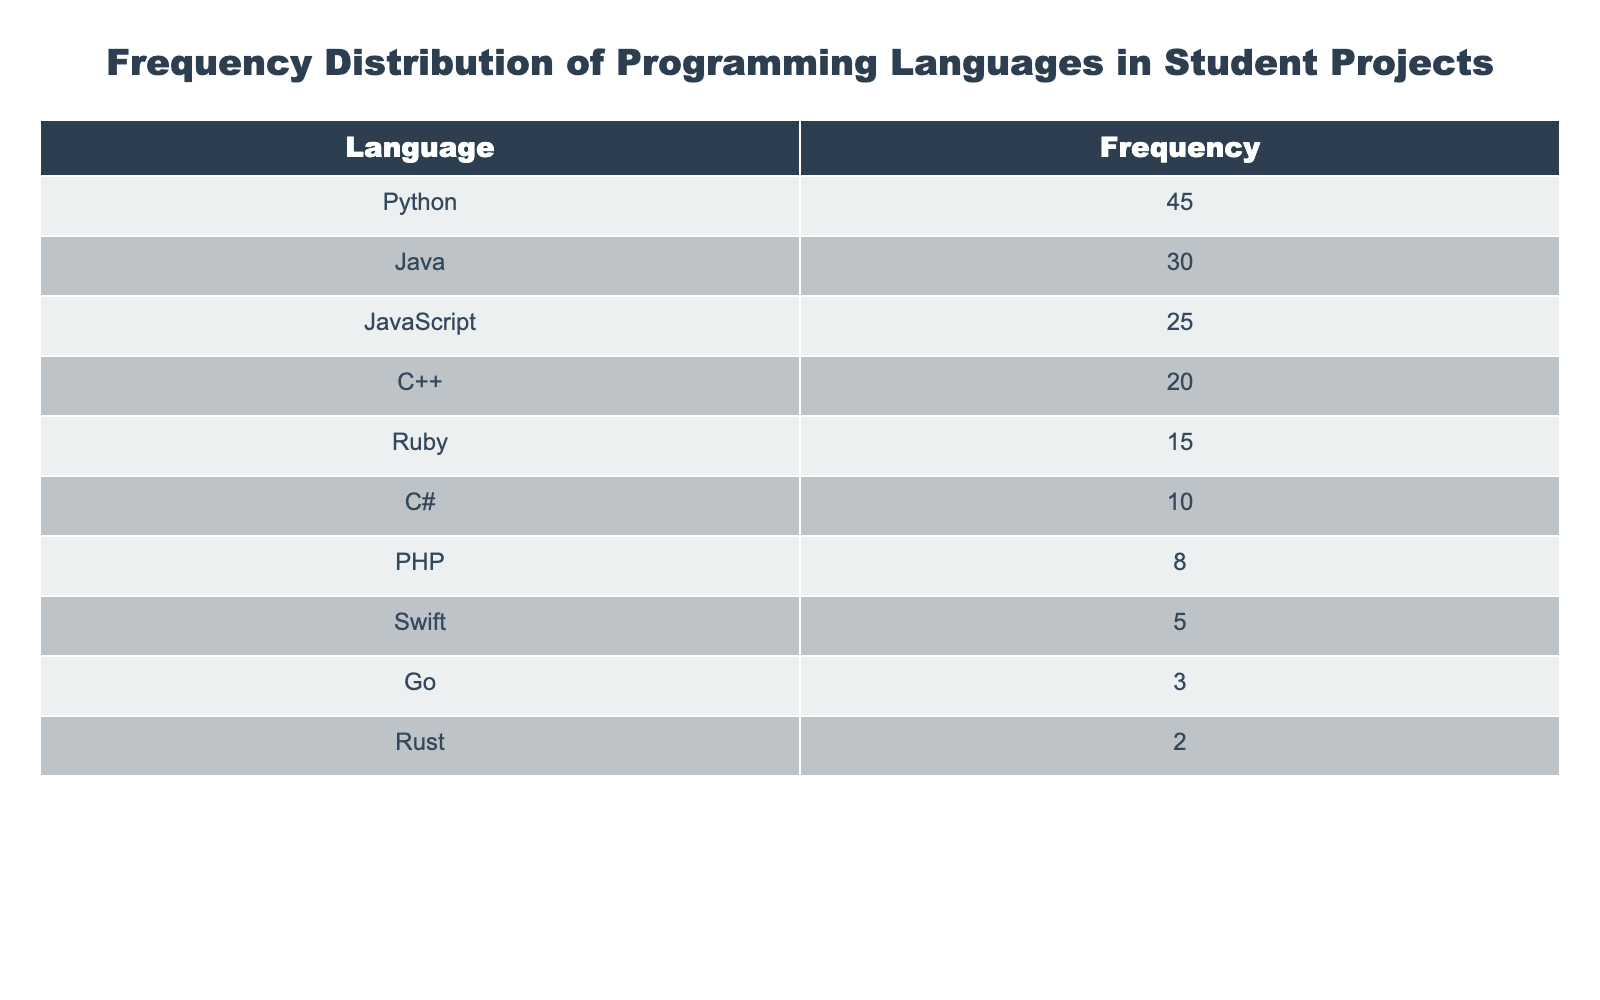What is the most commonly used programming language in student projects? The table lists the programming languages along with their respective frequencies. Looking at the frequency column, Python has the highest frequency of 45, making it the most commonly used language.
Answer: Python How many programming languages have a frequency of 10 or more? To find the number of programming languages with a frequency of 10 or more, we count the frequencies that meet this criterion: Python (45), Java (30), JavaScript (25), C++ (20), Ruby (15), C# (10). There are 6 languages that match.
Answer: 6 Is Rust one of the top three programming languages used in student projects? The table shows that Rust has a frequency of 2. Looking at the frequencies of the top three languages (Python, Java, and JavaScript), Rust does not fall within this group. Therefore, the answer is no.
Answer: No What is the frequency difference between Java and C++? The frequency for Java is 30, while for C++ it is 20. To find the difference, we subtract the frequency of C++ from that of Java: 30 - 20 = 10.
Answer: 10 If we combine the frequencies of Ruby, C#, and PHP, what is the total? The frequencies for those languages are: Ruby (15), C# (10), and PHP (8). Summing these values gives: 15 + 10 + 8 = 33. Therefore, the total frequency for these three languages is 33.
Answer: 33 How does the number of projects using JavaScript compare to those using Go? The table shows that JavaScript has a frequency of 25, and Go has a frequency of 3. To compare, we notice that JavaScript is used in 25 - 3 = 22 more projects than Go, indicating a significant difference.
Answer: JavaScript is used in 22 more projects than Go 